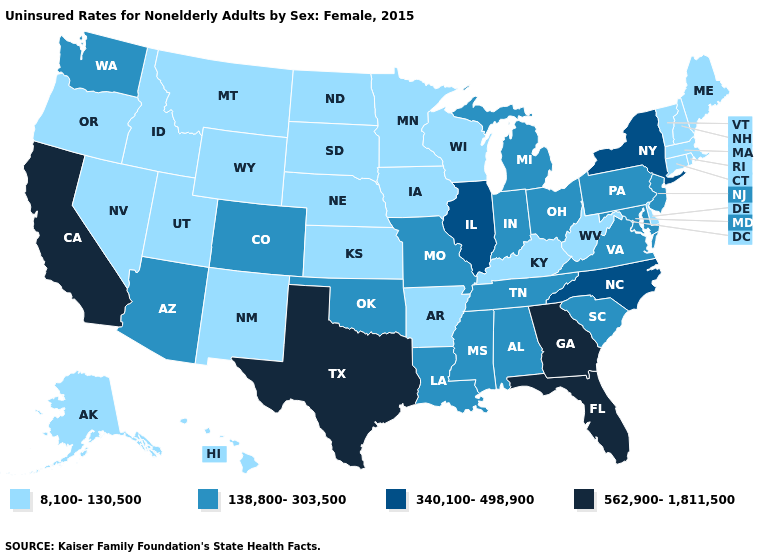Does the map have missing data?
Concise answer only. No. Among the states that border Kansas , which have the highest value?
Keep it brief. Colorado, Missouri, Oklahoma. What is the value of Ohio?
Answer briefly. 138,800-303,500. Does South Carolina have the lowest value in the USA?
Be succinct. No. What is the value of Idaho?
Short answer required. 8,100-130,500. Does North Carolina have the same value as Illinois?
Short answer required. Yes. Which states have the highest value in the USA?
Short answer required. California, Florida, Georgia, Texas. What is the value of Pennsylvania?
Concise answer only. 138,800-303,500. Among the states that border West Virginia , which have the lowest value?
Give a very brief answer. Kentucky. What is the value of Virginia?
Write a very short answer. 138,800-303,500. Name the states that have a value in the range 340,100-498,900?
Quick response, please. Illinois, New York, North Carolina. What is the value of Utah?
Be succinct. 8,100-130,500. What is the value of Maine?
Quick response, please. 8,100-130,500. What is the value of North Dakota?
Keep it brief. 8,100-130,500. What is the highest value in states that border Vermont?
Be succinct. 340,100-498,900. 